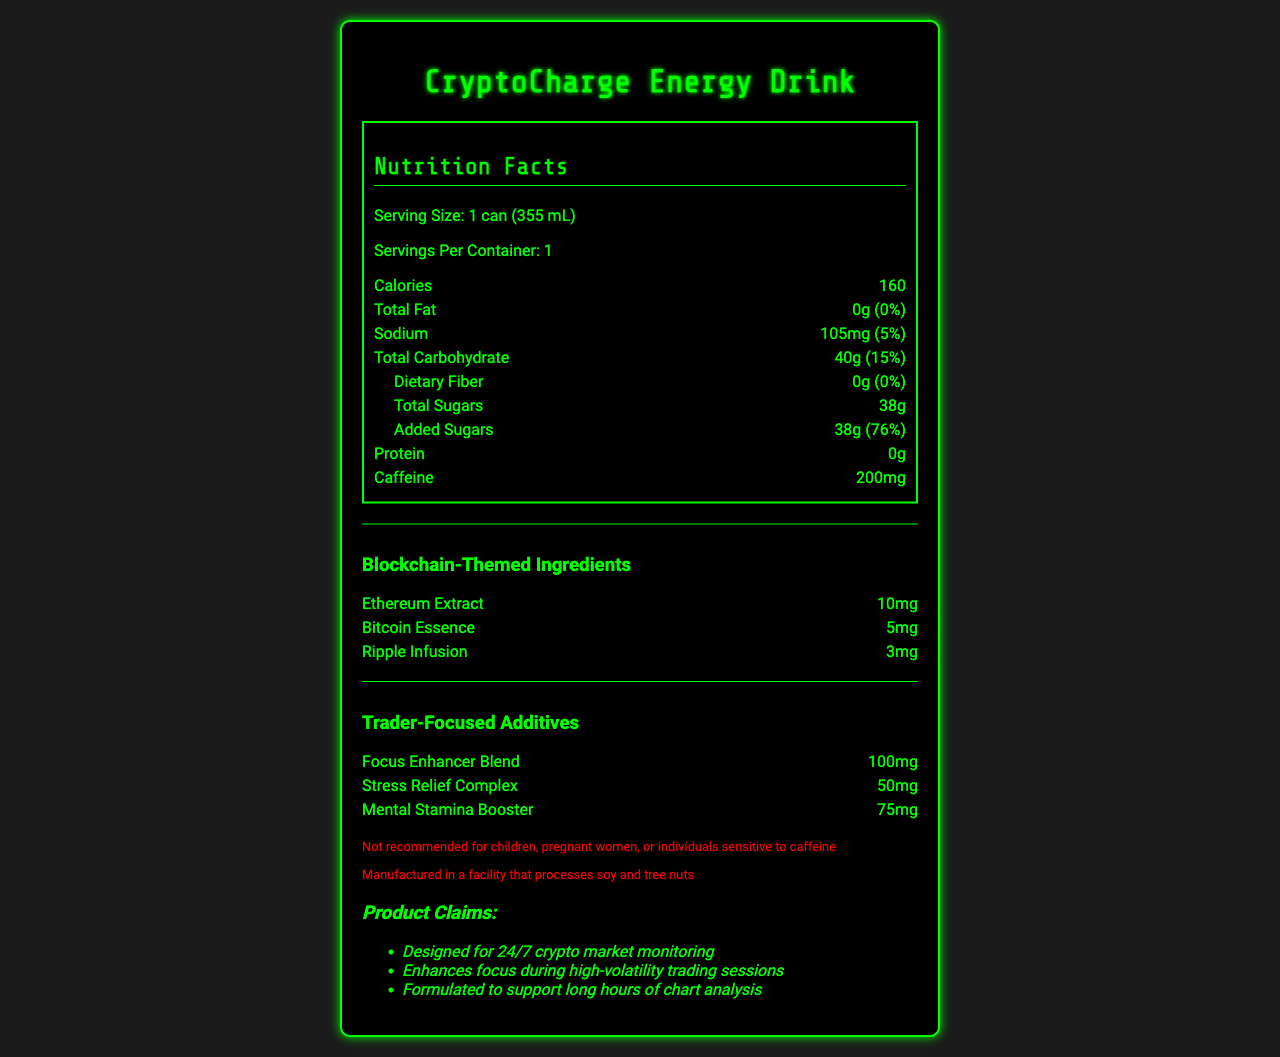what is the serving size of the CryptoCharge Energy Drink? The document states that the serving size is 1 can (355 mL).
Answer: 1 can (355 mL) how many calories are in one serving of the CryptoCharge Energy Drink? The document shows that each serving contains 160 calories.
Answer: 160 what percentage of daily value does the sodium content represent? The document specifies that the sodium content amounts to 5% of the daily value.
Answer: 5% what is the amount of added sugars in the CryptoCharge Energy Drink? The nutrition label indicates that the drink contains 38 grams of added sugars.
Answer: 38g what are the blockchain-themed ingredients in the drink? The section entitled "Blockchain-Themed Ingredients" lists Ethereum Extract, Bitcoin Essence, and Ripple Infusion.
Answer: Ethereum Extract, Bitcoin Essence, Ripple Infusion how much vitamin B12 does the CryptoCharge Energy Drink contain, and what percentage of the daily value does this represent? The document states that the drink contains 6μg of vitamin B12, which represents 250% of the daily value.
Answer: 6μg, 250% what is the total carbohydrate content? A. 20g B. 30g C. 40g D. 50g The document lists the total carbohydrate content as 40g.
Answer: C which trader-focused additive has the highest amount? I. Focus Enhancer Blend II. Stress Relief Complex III. Mental Stamina Booster The "Focus Enhancer Blend" has 100mg, Stress Relief Complex has 50mg, and Mental Stamina Booster has 75mg. Therefore, Focus Enhancer Blend has the highest amount.
Answer: I does the document mention whether the product is suitable for children or pregnant women? The disclaimer in the document states that the product is not recommended for children, pregnant women, or individuals sensitive to caffeine.
Answer: no summarize the main claims made about the CryptoCharge Energy Drink. The marketing claims section outlines that the product is designed for continuous market monitoring, improves focus during active trading periods, and supports extended chart analysis sessions.
Answer: The drink is designed for 24/7 crypto market monitoring, enhances focus during high-volatility trading sessions, and is formulated to support long hours of chart analysis. what is the protein content of the CryptoCharge Energy Drink? The document states that the protein content is 0 grams.
Answer: 0g is the sodium content higher than the dietary fiber content? The sodium content is 105mg, while the dietary fiber content is 0g, so the sodium content is indeed higher.
Answer: Yes based on the nutrient data provided, what can be inferred about the product's suitability for individuals monitoring their sugar intake? The "Total Sugars" section indicates significant added sugars, contributing to a large portion of the daily value, suggesting it may not be appropriate for those needing to manage their sugar consumption.
Answer: The drink contains 38g of added sugars, which is 76% of the daily value, indicating that it has high sugar content and may not be suitable for individuals monitoring their sugar intake. can you determine from the document if the product is vegan or vegetarian? The document does not provide any information about whether the product is vegan or vegetarian.
Answer: Not enough information 